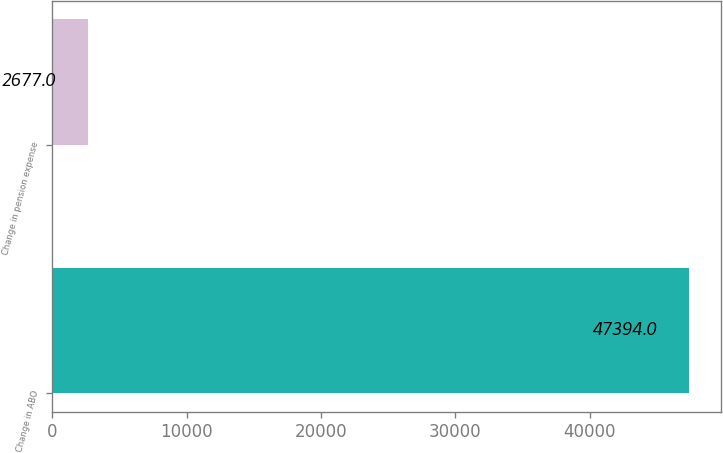<chart> <loc_0><loc_0><loc_500><loc_500><bar_chart><fcel>Change in ABO<fcel>Change in pension expense<nl><fcel>47394<fcel>2677<nl></chart> 